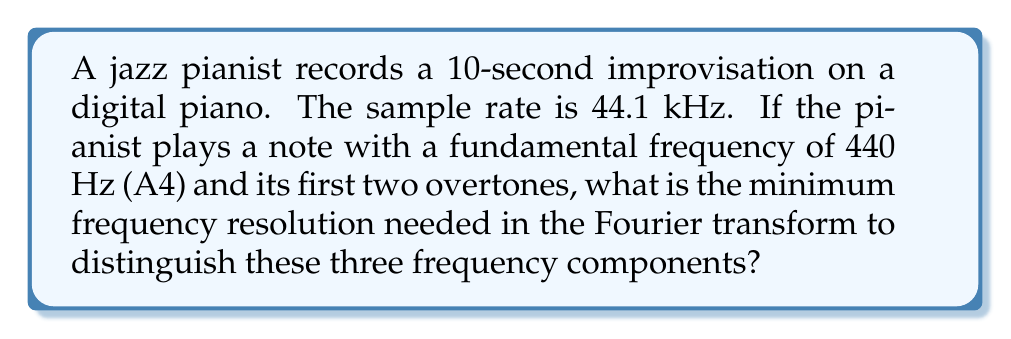Can you answer this question? Let's approach this step-by-step:

1) The Fourier transform of a discrete-time signal gives us a frequency spectrum. The frequency resolution $\Delta f$ of a Discrete Fourier Transform (DFT) is given by:

   $$\Delta f = \frac{f_s}{N}$$

   where $f_s$ is the sampling frequency and $N$ is the number of samples.

2) We're given that the sample rate is 44.1 kHz, so $f_s = 44100$ Hz.

3) The recording duration is 10 seconds, so the total number of samples is:

   $$N = f_s \times \text{duration} = 44100 \times 10 = 441000$$

4) The fundamental frequency is 440 Hz (A4). The first two overtones will be:
   - First overtone: $2 \times 440 = 880$ Hz
   - Second overtone: $3 \times 440 = 1320$ Hz

5) To distinguish these frequencies, we need a frequency resolution that's smaller than the smallest difference between any two of these frequencies. The smallest difference is between the fundamental and the first overtone:

   $$880 \text{ Hz} - 440 \text{ Hz} = 440 \text{ Hz}$$

6) Therefore, we need $\Delta f < 440$ Hz. Let's calculate the actual frequency resolution:

   $$\Delta f = \frac{f_s}{N} = \frac{44100}{441000} = 0.1 \text{ Hz}$$

7) This resolution (0.1 Hz) is much finer than the 440 Hz difference we need to distinguish the frequencies, so it's more than sufficient.
Answer: 0.1 Hz 